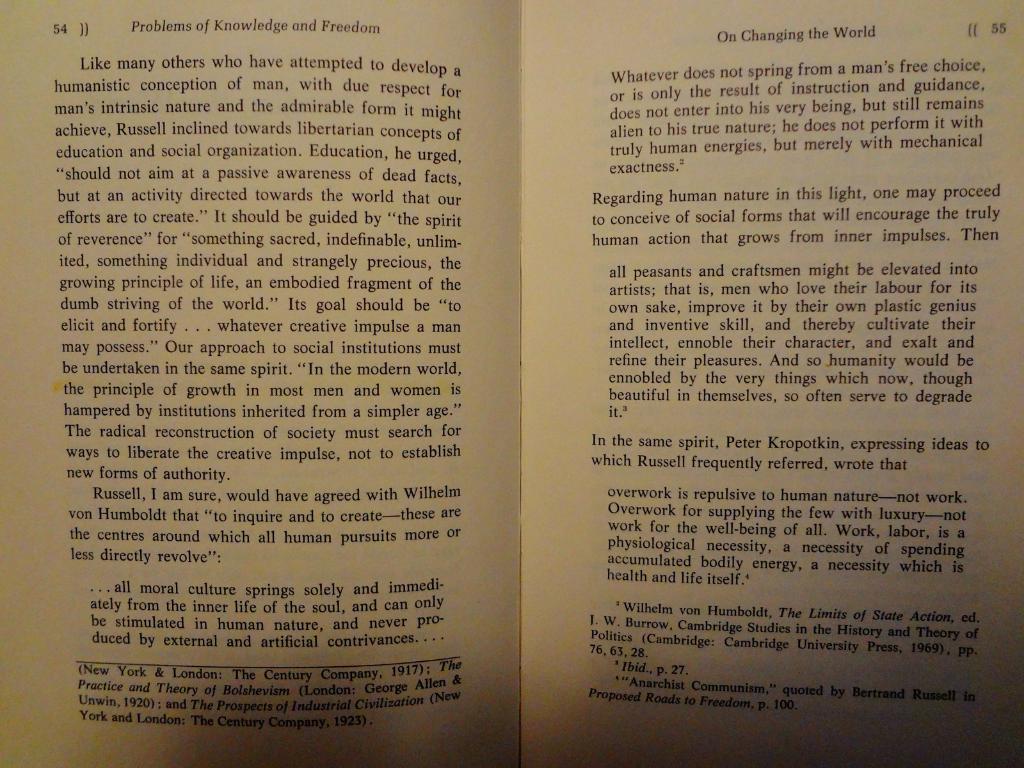What number page is on the left?
Offer a terse response. 54. What is the name of the chapter on the right page?
Your response must be concise. On changing the world. 